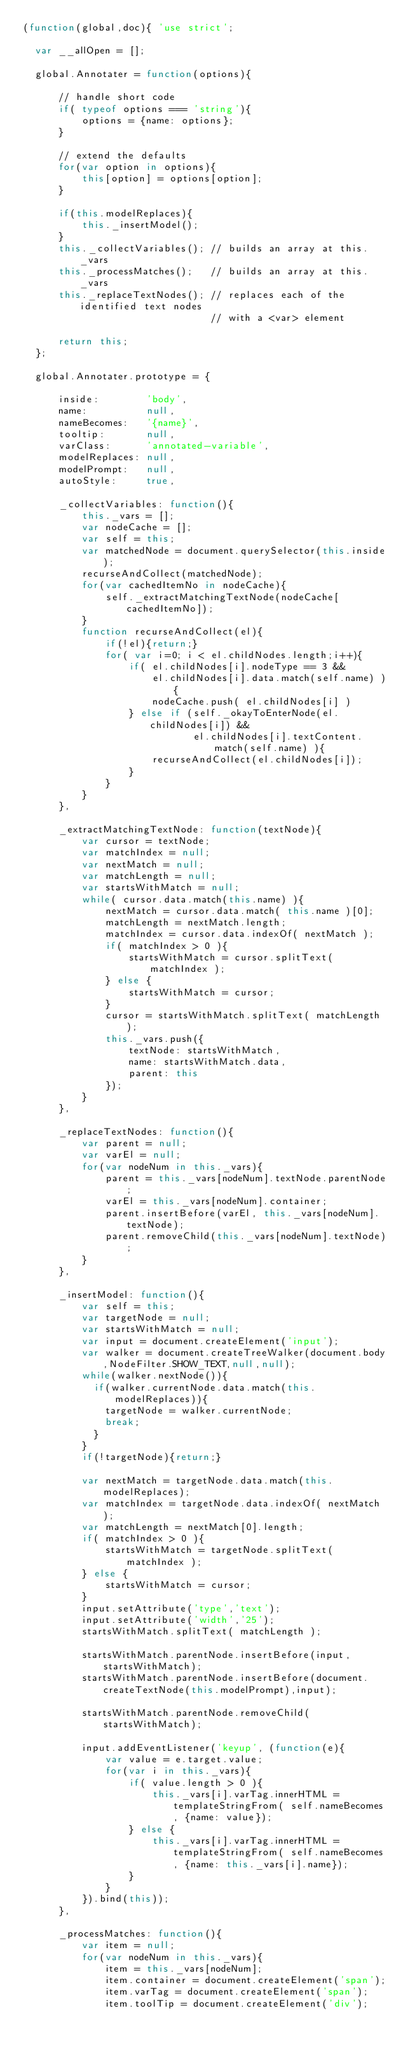Convert code to text. <code><loc_0><loc_0><loc_500><loc_500><_JavaScript_>(function(global,doc){ 'use strict';

  var __allOpen = [];

  global.Annotater = function(options){

      // handle short code
      if( typeof options === 'string'){
          options = {name: options};
      }

      // extend the defaults
      for(var option in options){
          this[option] = options[option];
      }

      if(this.modelReplaces){
          this._insertModel();
      }
      this._collectVariables(); // builds an array at this._vars
      this._processMatches();   // builds an array at this._vars
      this._replaceTextNodes(); // replaces each of the identified text nodes
                                // with a <var> element

      return this;
  };

  global.Annotater.prototype = {

      inside:        'body',
      name:          null,
      nameBecomes:   '{name}',
      tooltip:       null,
      varClass:      'annotated-variable',
      modelReplaces: null,
      modelPrompt:   null,
      autoStyle:     true,

      _collectVariables: function(){
          this._vars = [];
          var nodeCache = [];
          var self = this;
          var matchedNode = document.querySelector(this.inside);
          recurseAndCollect(matchedNode);
          for(var cachedItemNo in nodeCache){
              self._extractMatchingTextNode(nodeCache[cachedItemNo]);
          }
          function recurseAndCollect(el){
              if(!el){return;}
              for( var i=0; i < el.childNodes.length;i++){
                  if( el.childNodes[i].nodeType == 3 &&
                      el.childNodes[i].data.match(self.name) ){
                      nodeCache.push( el.childNodes[i] )
                  } else if (self._okayToEnterNode(el.childNodes[i]) &&
                             el.childNodes[i].textContent.match(self.name) ){
                      recurseAndCollect(el.childNodes[i]);
                  }
              }
          }
      },

      _extractMatchingTextNode: function(textNode){
          var cursor = textNode;
          var matchIndex = null;
          var nextMatch = null;
          var matchLength = null;
          var startsWithMatch = null;
          while( cursor.data.match(this.name) ){
              nextMatch = cursor.data.match( this.name )[0];
              matchLength = nextMatch.length;
              matchIndex = cursor.data.indexOf( nextMatch );
              if( matchIndex > 0 ){
                  startsWithMatch = cursor.splitText( matchIndex );
              } else {
                  startsWithMatch = cursor;
              }
              cursor = startsWithMatch.splitText( matchLength );
              this._vars.push({
                  textNode: startsWithMatch,
                  name: startsWithMatch.data,
                  parent: this
              });
          }
      },

      _replaceTextNodes: function(){
          var parent = null;
          var varEl = null;
          for(var nodeNum in this._vars){
              parent = this._vars[nodeNum].textNode.parentNode;
              varEl = this._vars[nodeNum].container;
              parent.insertBefore(varEl, this._vars[nodeNum].textNode);
              parent.removeChild(this._vars[nodeNum].textNode);
          }
      },

      _insertModel: function(){
          var self = this;
          var targetNode = null;
          var startsWithMatch = null;
          var input = document.createElement('input');
          var walker = document.createTreeWalker(document.body,NodeFilter.SHOW_TEXT,null,null);
          while(walker.nextNode()){
            if(walker.currentNode.data.match(this.modelReplaces)){
              targetNode = walker.currentNode;
              break;
            }
          }
          if(!targetNode){return;}

          var nextMatch = targetNode.data.match(this.modelReplaces);
          var matchIndex = targetNode.data.indexOf( nextMatch );
          var matchLength = nextMatch[0].length;
          if( matchIndex > 0 ){
              startsWithMatch = targetNode.splitText( matchIndex );
          } else {
              startsWithMatch = cursor;
          }
          input.setAttribute('type','text');
          input.setAttribute('width','25');
          startsWithMatch.splitText( matchLength );

          startsWithMatch.parentNode.insertBefore(input,startsWithMatch);
          startsWithMatch.parentNode.insertBefore(document.createTextNode(this.modelPrompt),input);

          startsWithMatch.parentNode.removeChild(startsWithMatch);

          input.addEventListener('keyup', (function(e){
              var value = e.target.value;
              for(var i in this._vars){
                  if( value.length > 0 ){
                      this._vars[i].varTag.innerHTML = templateStringFrom( self.nameBecomes, {name: value});
                  } else {
                      this._vars[i].varTag.innerHTML = templateStringFrom( self.nameBecomes, {name: this._vars[i].name});
                  }
              }
          }).bind(this));
      },

      _processMatches: function(){
          var item = null;
          for(var nodeNum in this._vars){
              item = this._vars[nodeNum];
              item.container = document.createElement('span');
              item.varTag = document.createElement('span');
              item.toolTip = document.createElement('div');</code> 